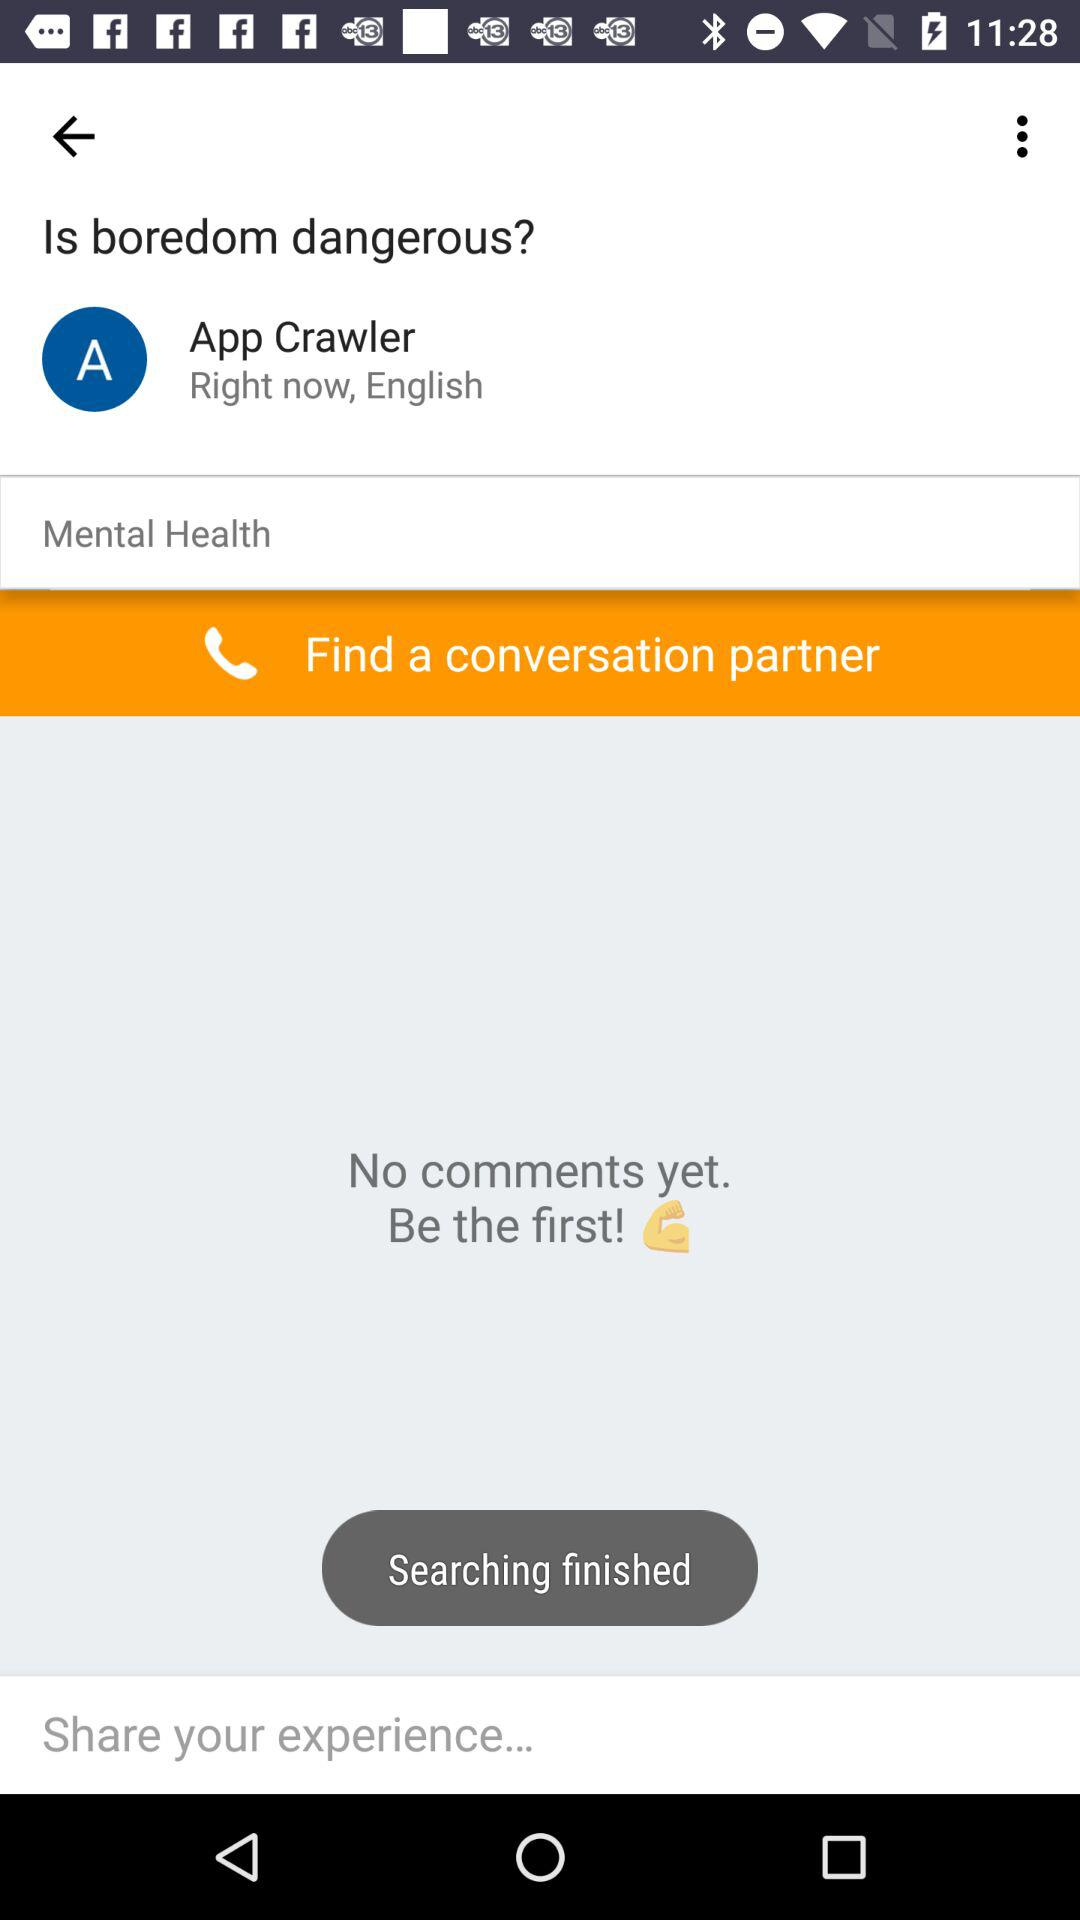What features can be seen on this interface that are typical for social platforms? The interface includes features like a prominent question or topic header, profile information for the poster, a call to action to find a conversation partner, and an input field prompting users to share their experience, which are typical for many social discussion platforms. 